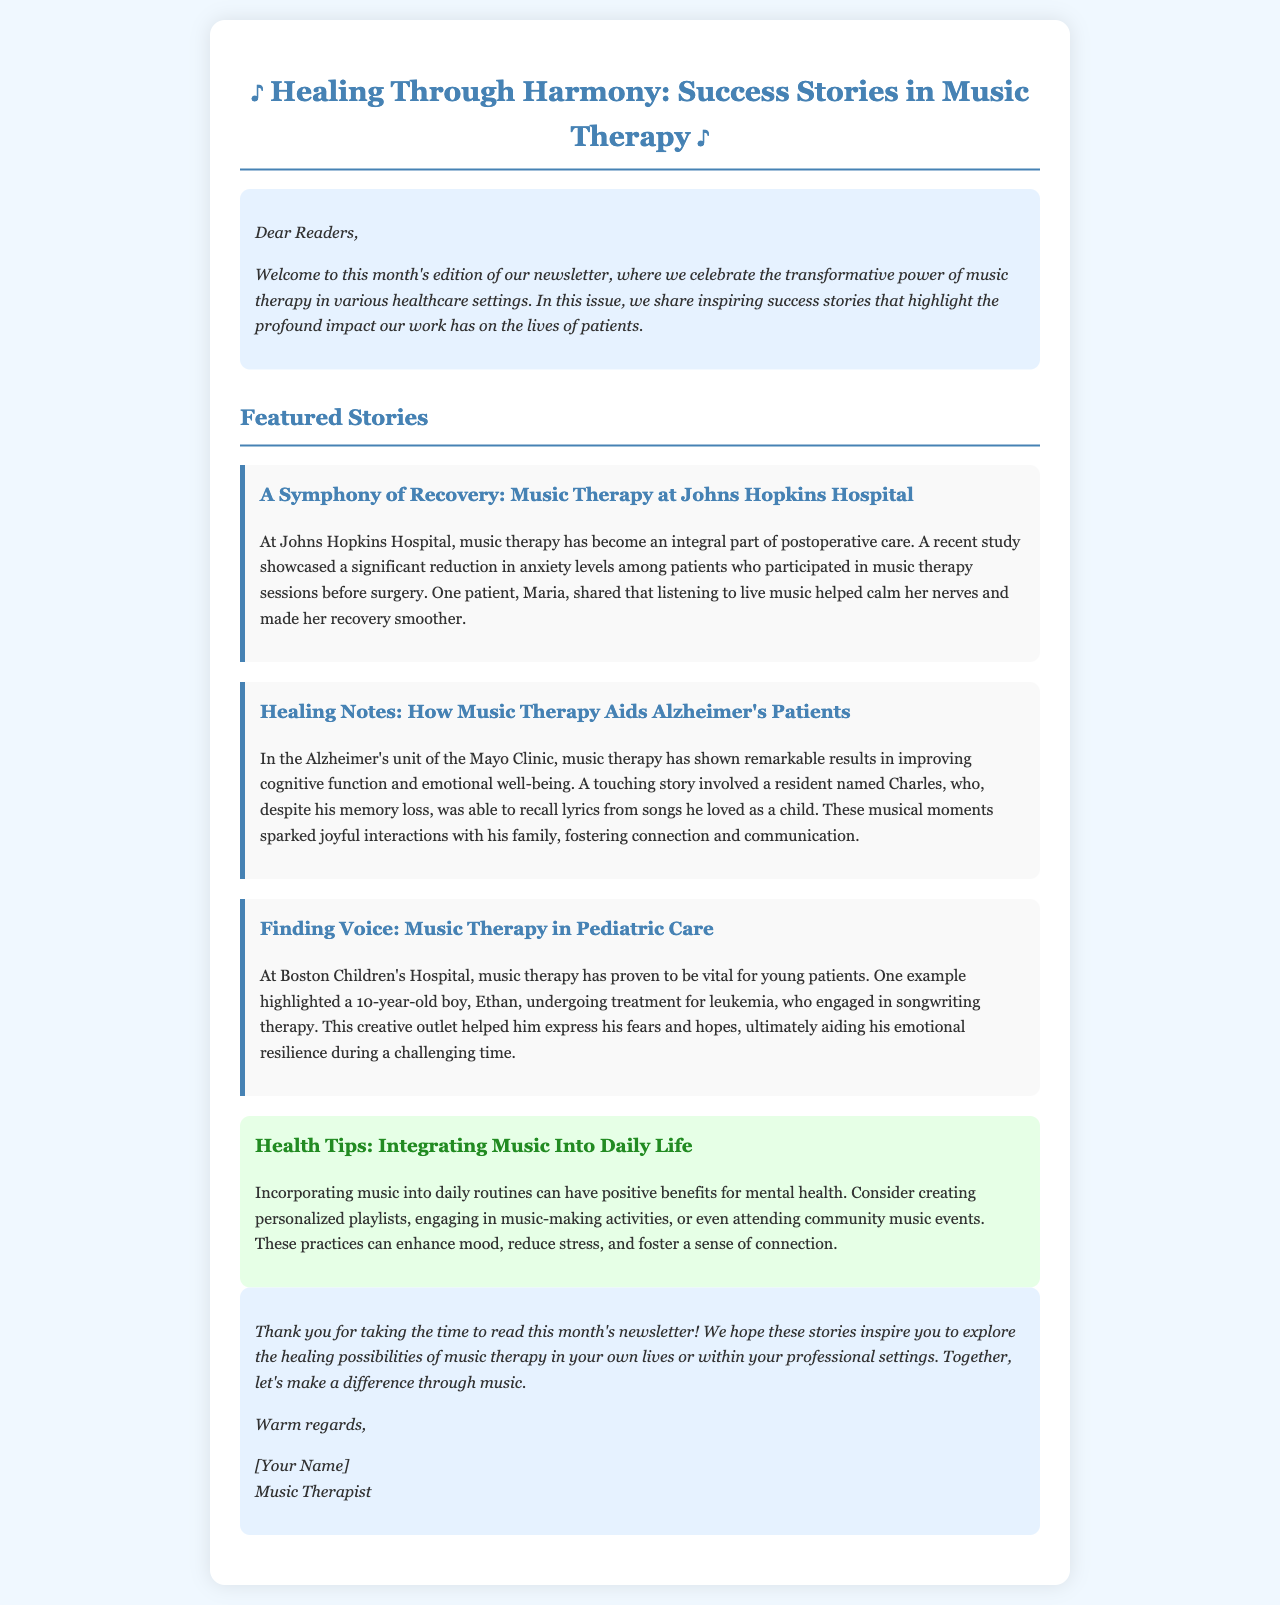What is the title of the newsletter? The title of the newsletter is stated at the top of the document.
Answer: Healing Through Harmony: Success Stories in Music Therapy Who is one patient mentioned from Johns Hopkins Hospital? The document provides the name of a patient who shared her experience with music therapy.
Answer: Maria What condition was Ethan undergoing treatment for? The document specifies the condition Ethan was being treated for in the pediatric care section.
Answer: Leukemia Which clinic is associated with the story of Alzheimer's patients? The document mentions a specific clinic that features success with music therapy for Alzheimer's patients.
Answer: Mayo Clinic What type of activity helped Charles reconnect with his family? The document describes an activity that facilitated interactions for a specific patient.
Answer: Musical moments In how many healthcare settings are success stories highlighted? The document lists multiple success stories across different settings, which can be counted.
Answer: Three What is one health tip provided in the newsletter? The document contains suggestions for incorporating music into daily life, highlighting one useful practice.
Answer: Creating personalized playlists Who authored the newsletter? The closing section of the document identifies the sender of the newsletter.
Answer: [Your Name] What does the newsletter encourage readers to do? The document expresses a call to action at the end of the newsletter summarizing its hopes for the audience.
Answer: Explore the healing possibilities of music therapy 